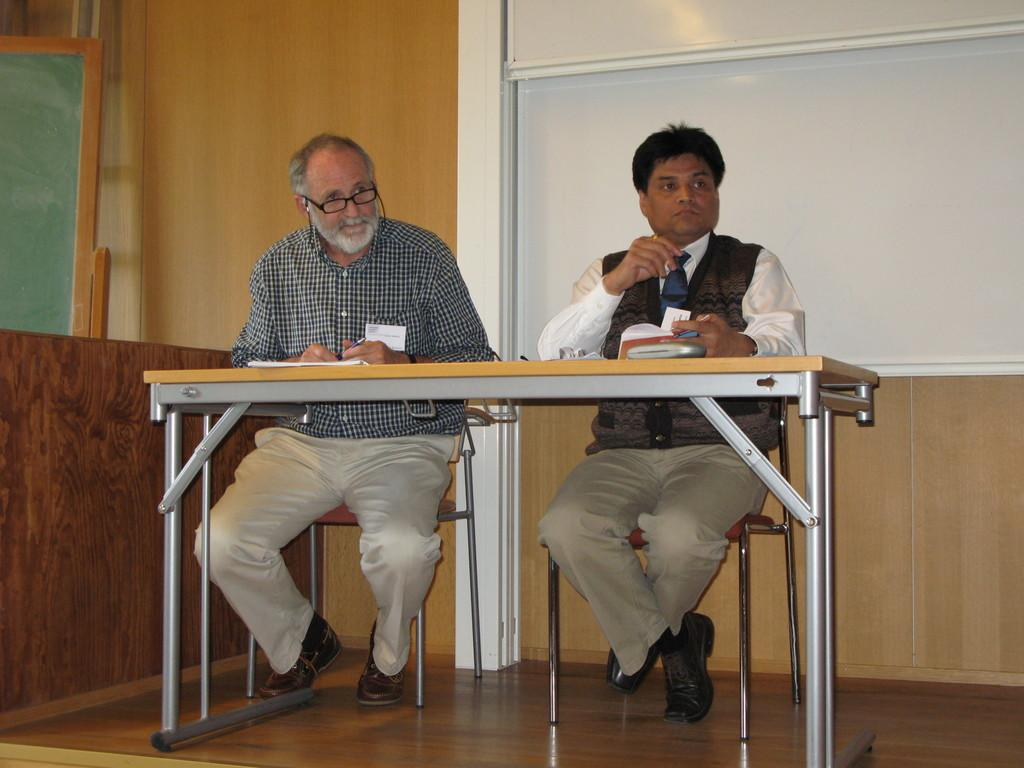How many men are present in the image? There are two men in the image. What are the men doing in the image? The men are sitting on chairs. What is located in front of the men? The men are in front of a table. Where does the scene take place? The scene takes place in a room. What type of neck accessory is the man on the left wearing in the image? There is no neck accessory mentioned or visible in the image. Are there any berries on the table in the image? There is no mention or indication of berries being present on the table in the image. 